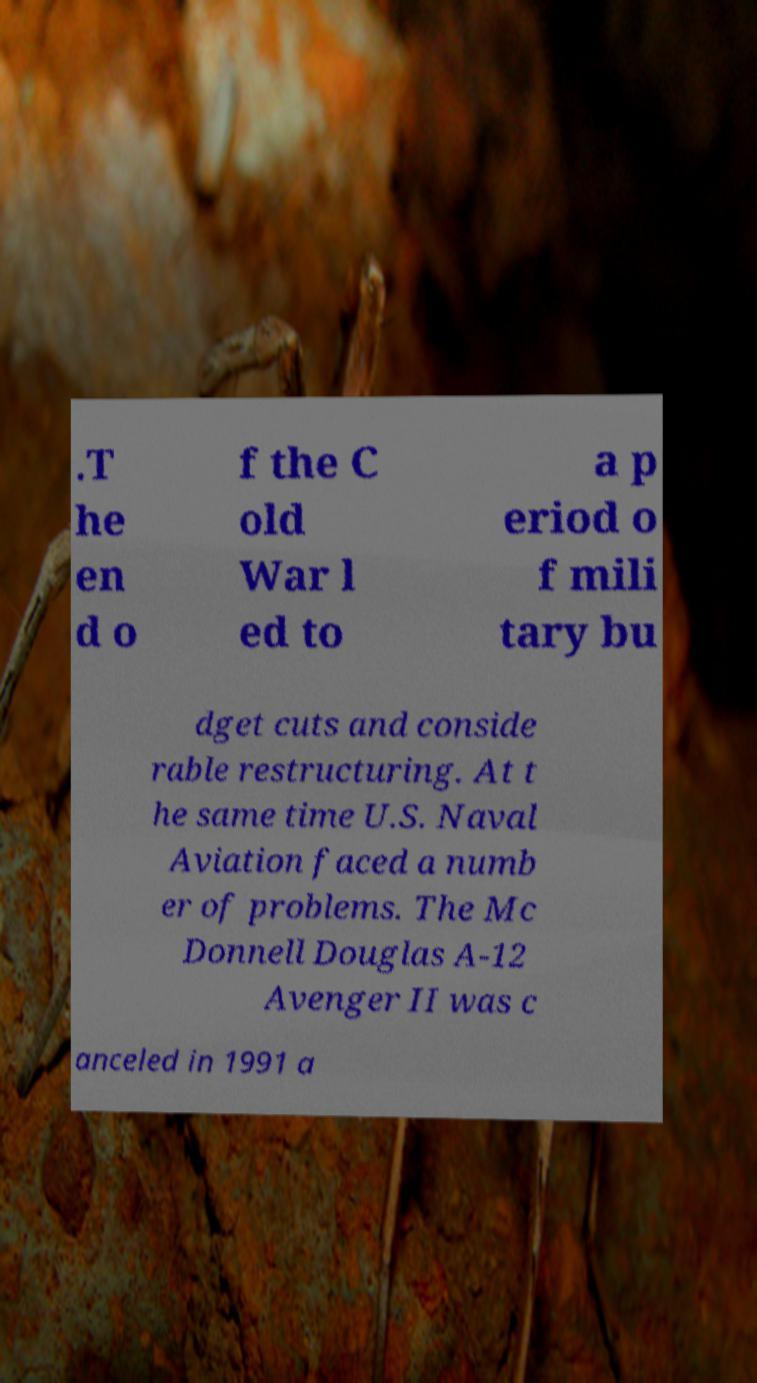Can you read and provide the text displayed in the image?This photo seems to have some interesting text. Can you extract and type it out for me? .T he en d o f the C old War l ed to a p eriod o f mili tary bu dget cuts and conside rable restructuring. At t he same time U.S. Naval Aviation faced a numb er of problems. The Mc Donnell Douglas A-12 Avenger II was c anceled in 1991 a 